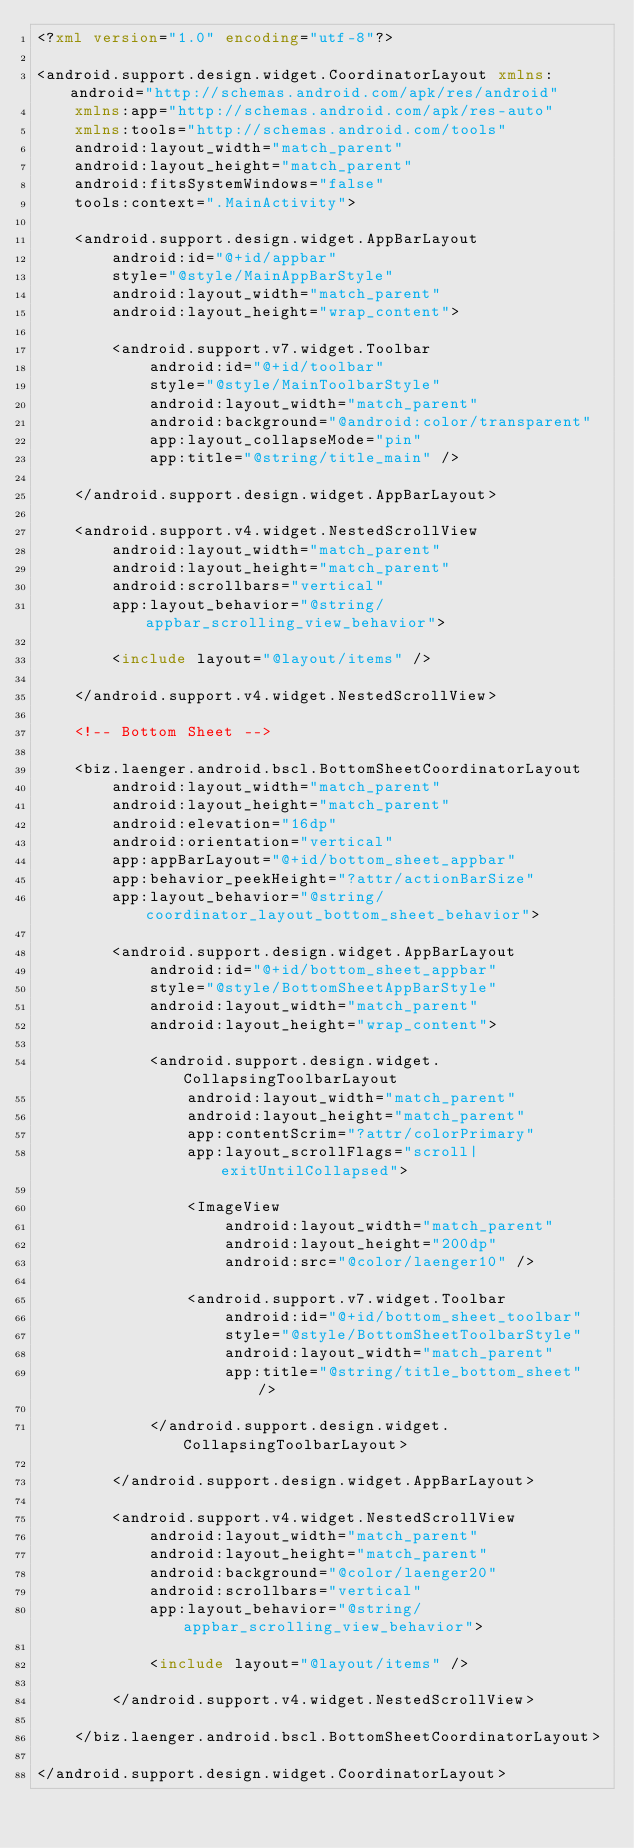<code> <loc_0><loc_0><loc_500><loc_500><_XML_><?xml version="1.0" encoding="utf-8"?>

<android.support.design.widget.CoordinatorLayout xmlns:android="http://schemas.android.com/apk/res/android"
    xmlns:app="http://schemas.android.com/apk/res-auto"
    xmlns:tools="http://schemas.android.com/tools"
    android:layout_width="match_parent"
    android:layout_height="match_parent"
    android:fitsSystemWindows="false"
    tools:context=".MainActivity">

    <android.support.design.widget.AppBarLayout
        android:id="@+id/appbar"
        style="@style/MainAppBarStyle"
        android:layout_width="match_parent"
        android:layout_height="wrap_content">

        <android.support.v7.widget.Toolbar
            android:id="@+id/toolbar"
            style="@style/MainToolbarStyle"
            android:layout_width="match_parent"
            android:background="@android:color/transparent"
            app:layout_collapseMode="pin"
            app:title="@string/title_main" />

    </android.support.design.widget.AppBarLayout>

    <android.support.v4.widget.NestedScrollView
        android:layout_width="match_parent"
        android:layout_height="match_parent"
        android:scrollbars="vertical"
        app:layout_behavior="@string/appbar_scrolling_view_behavior">

        <include layout="@layout/items" />

    </android.support.v4.widget.NestedScrollView>

    <!-- Bottom Sheet -->

    <biz.laenger.android.bscl.BottomSheetCoordinatorLayout
        android:layout_width="match_parent"
        android:layout_height="match_parent"
        android:elevation="16dp"
        android:orientation="vertical"
        app:appBarLayout="@+id/bottom_sheet_appbar"
        app:behavior_peekHeight="?attr/actionBarSize"
        app:layout_behavior="@string/coordinator_layout_bottom_sheet_behavior">

        <android.support.design.widget.AppBarLayout
            android:id="@+id/bottom_sheet_appbar"
            style="@style/BottomSheetAppBarStyle"
            android:layout_width="match_parent"
            android:layout_height="wrap_content">

            <android.support.design.widget.CollapsingToolbarLayout
                android:layout_width="match_parent"
                android:layout_height="match_parent"
                app:contentScrim="?attr/colorPrimary"
                app:layout_scrollFlags="scroll|exitUntilCollapsed">

                <ImageView
                    android:layout_width="match_parent"
                    android:layout_height="200dp"
                    android:src="@color/laenger10" />

                <android.support.v7.widget.Toolbar
                    android:id="@+id/bottom_sheet_toolbar"
                    style="@style/BottomSheetToolbarStyle"
                    android:layout_width="match_parent"
                    app:title="@string/title_bottom_sheet" />

            </android.support.design.widget.CollapsingToolbarLayout>

        </android.support.design.widget.AppBarLayout>

        <android.support.v4.widget.NestedScrollView
            android:layout_width="match_parent"
            android:layout_height="match_parent"
            android:background="@color/laenger20"
            android:scrollbars="vertical"
            app:layout_behavior="@string/appbar_scrolling_view_behavior">

            <include layout="@layout/items" />

        </android.support.v4.widget.NestedScrollView>

    </biz.laenger.android.bscl.BottomSheetCoordinatorLayout>

</android.support.design.widget.CoordinatorLayout>
</code> 